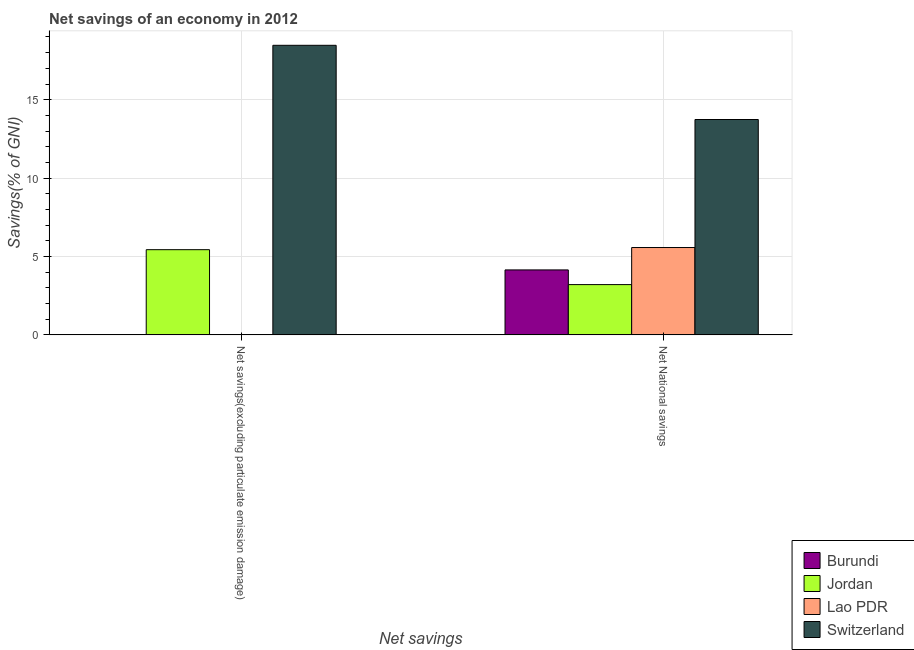How many different coloured bars are there?
Your response must be concise. 4. How many groups of bars are there?
Provide a succinct answer. 2. Are the number of bars on each tick of the X-axis equal?
Your answer should be compact. No. How many bars are there on the 1st tick from the right?
Provide a short and direct response. 4. What is the label of the 1st group of bars from the left?
Offer a terse response. Net savings(excluding particulate emission damage). What is the net national savings in Burundi?
Make the answer very short. 4.14. Across all countries, what is the maximum net savings(excluding particulate emission damage)?
Ensure brevity in your answer.  18.47. In which country was the net national savings maximum?
Provide a succinct answer. Switzerland. What is the total net national savings in the graph?
Your answer should be very brief. 26.66. What is the difference between the net national savings in Lao PDR and that in Burundi?
Make the answer very short. 1.43. What is the difference between the net savings(excluding particulate emission damage) in Burundi and the net national savings in Jordan?
Your response must be concise. -3.21. What is the average net national savings per country?
Your response must be concise. 6.66. What is the difference between the net national savings and net savings(excluding particulate emission damage) in Switzerland?
Make the answer very short. -4.73. In how many countries, is the net national savings greater than 13 %?
Provide a short and direct response. 1. What is the ratio of the net national savings in Burundi to that in Lao PDR?
Keep it short and to the point. 0.74. In how many countries, is the net savings(excluding particulate emission damage) greater than the average net savings(excluding particulate emission damage) taken over all countries?
Your response must be concise. 1. Are all the bars in the graph horizontal?
Keep it short and to the point. No. What is the difference between two consecutive major ticks on the Y-axis?
Provide a succinct answer. 5. Are the values on the major ticks of Y-axis written in scientific E-notation?
Your answer should be compact. No. What is the title of the graph?
Give a very brief answer. Net savings of an economy in 2012. Does "Gambia, The" appear as one of the legend labels in the graph?
Your answer should be compact. No. What is the label or title of the X-axis?
Offer a very short reply. Net savings. What is the label or title of the Y-axis?
Provide a succinct answer. Savings(% of GNI). What is the Savings(% of GNI) of Burundi in Net savings(excluding particulate emission damage)?
Ensure brevity in your answer.  0. What is the Savings(% of GNI) of Jordan in Net savings(excluding particulate emission damage)?
Your response must be concise. 5.43. What is the Savings(% of GNI) in Switzerland in Net savings(excluding particulate emission damage)?
Keep it short and to the point. 18.47. What is the Savings(% of GNI) of Burundi in Net National savings?
Provide a short and direct response. 4.14. What is the Savings(% of GNI) of Jordan in Net National savings?
Keep it short and to the point. 3.21. What is the Savings(% of GNI) in Lao PDR in Net National savings?
Your answer should be compact. 5.57. What is the Savings(% of GNI) in Switzerland in Net National savings?
Provide a succinct answer. 13.74. Across all Net savings, what is the maximum Savings(% of GNI) of Burundi?
Ensure brevity in your answer.  4.14. Across all Net savings, what is the maximum Savings(% of GNI) of Jordan?
Offer a very short reply. 5.43. Across all Net savings, what is the maximum Savings(% of GNI) of Lao PDR?
Your answer should be compact. 5.57. Across all Net savings, what is the maximum Savings(% of GNI) in Switzerland?
Make the answer very short. 18.47. Across all Net savings, what is the minimum Savings(% of GNI) in Jordan?
Your response must be concise. 3.21. Across all Net savings, what is the minimum Savings(% of GNI) in Lao PDR?
Make the answer very short. 0. Across all Net savings, what is the minimum Savings(% of GNI) in Switzerland?
Give a very brief answer. 13.74. What is the total Savings(% of GNI) in Burundi in the graph?
Ensure brevity in your answer.  4.14. What is the total Savings(% of GNI) of Jordan in the graph?
Provide a short and direct response. 8.64. What is the total Savings(% of GNI) of Lao PDR in the graph?
Your answer should be very brief. 5.57. What is the total Savings(% of GNI) of Switzerland in the graph?
Provide a succinct answer. 32.21. What is the difference between the Savings(% of GNI) in Jordan in Net savings(excluding particulate emission damage) and that in Net National savings?
Offer a very short reply. 2.23. What is the difference between the Savings(% of GNI) of Switzerland in Net savings(excluding particulate emission damage) and that in Net National savings?
Offer a terse response. 4.73. What is the difference between the Savings(% of GNI) of Jordan in Net savings(excluding particulate emission damage) and the Savings(% of GNI) of Lao PDR in Net National savings?
Provide a succinct answer. -0.14. What is the difference between the Savings(% of GNI) of Jordan in Net savings(excluding particulate emission damage) and the Savings(% of GNI) of Switzerland in Net National savings?
Ensure brevity in your answer.  -8.3. What is the average Savings(% of GNI) of Burundi per Net savings?
Your answer should be very brief. 2.07. What is the average Savings(% of GNI) in Jordan per Net savings?
Offer a terse response. 4.32. What is the average Savings(% of GNI) of Lao PDR per Net savings?
Your response must be concise. 2.79. What is the average Savings(% of GNI) of Switzerland per Net savings?
Ensure brevity in your answer.  16.1. What is the difference between the Savings(% of GNI) of Jordan and Savings(% of GNI) of Switzerland in Net savings(excluding particulate emission damage)?
Your answer should be very brief. -13.03. What is the difference between the Savings(% of GNI) in Burundi and Savings(% of GNI) in Jordan in Net National savings?
Provide a succinct answer. 0.94. What is the difference between the Savings(% of GNI) of Burundi and Savings(% of GNI) of Lao PDR in Net National savings?
Give a very brief answer. -1.43. What is the difference between the Savings(% of GNI) of Burundi and Savings(% of GNI) of Switzerland in Net National savings?
Your response must be concise. -9.59. What is the difference between the Savings(% of GNI) in Jordan and Savings(% of GNI) in Lao PDR in Net National savings?
Provide a short and direct response. -2.36. What is the difference between the Savings(% of GNI) of Jordan and Savings(% of GNI) of Switzerland in Net National savings?
Offer a very short reply. -10.53. What is the difference between the Savings(% of GNI) in Lao PDR and Savings(% of GNI) in Switzerland in Net National savings?
Make the answer very short. -8.16. What is the ratio of the Savings(% of GNI) in Jordan in Net savings(excluding particulate emission damage) to that in Net National savings?
Offer a very short reply. 1.69. What is the ratio of the Savings(% of GNI) of Switzerland in Net savings(excluding particulate emission damage) to that in Net National savings?
Keep it short and to the point. 1.34. What is the difference between the highest and the second highest Savings(% of GNI) in Jordan?
Provide a short and direct response. 2.23. What is the difference between the highest and the second highest Savings(% of GNI) of Switzerland?
Offer a terse response. 4.73. What is the difference between the highest and the lowest Savings(% of GNI) in Burundi?
Offer a terse response. 4.14. What is the difference between the highest and the lowest Savings(% of GNI) of Jordan?
Offer a terse response. 2.23. What is the difference between the highest and the lowest Savings(% of GNI) in Lao PDR?
Provide a succinct answer. 5.57. What is the difference between the highest and the lowest Savings(% of GNI) of Switzerland?
Provide a succinct answer. 4.73. 